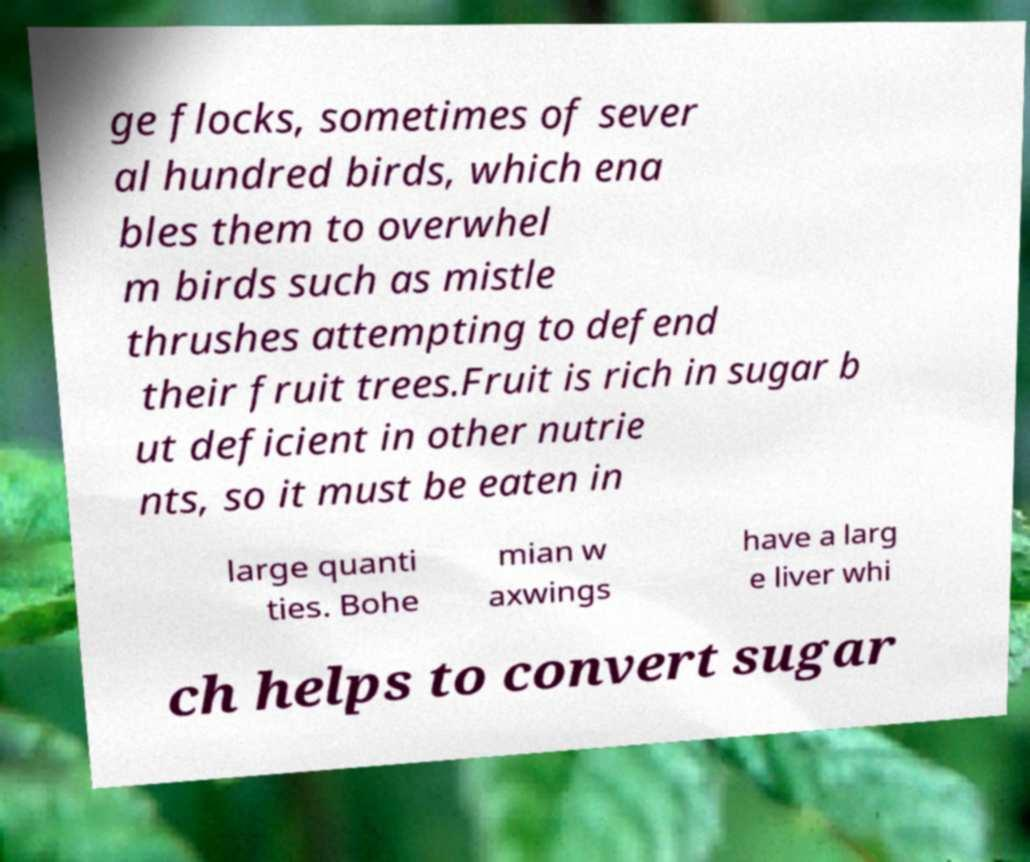Please read and relay the text visible in this image. What does it say? ge flocks, sometimes of sever al hundred birds, which ena bles them to overwhel m birds such as mistle thrushes attempting to defend their fruit trees.Fruit is rich in sugar b ut deficient in other nutrie nts, so it must be eaten in large quanti ties. Bohe mian w axwings have a larg e liver whi ch helps to convert sugar 